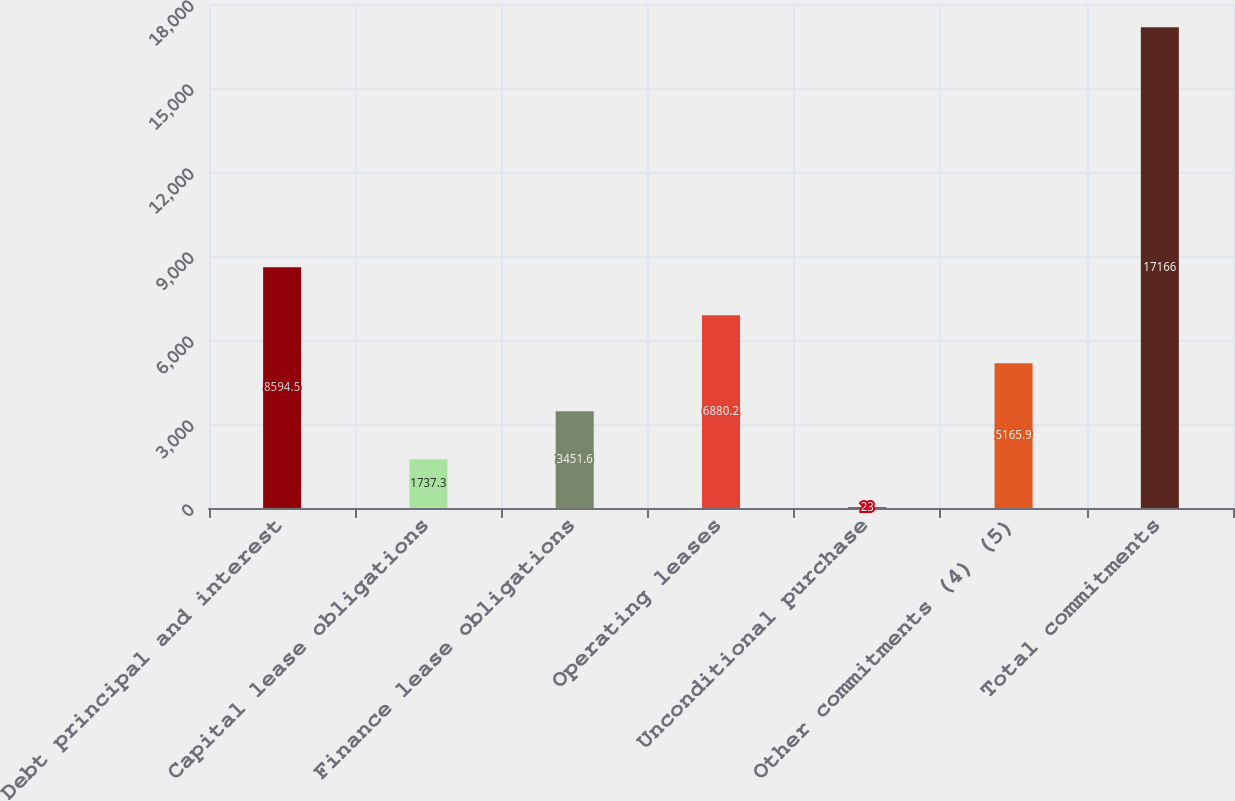Convert chart to OTSL. <chart><loc_0><loc_0><loc_500><loc_500><bar_chart><fcel>Debt principal and interest<fcel>Capital lease obligations<fcel>Finance lease obligations<fcel>Operating leases<fcel>Unconditional purchase<fcel>Other commitments (4) (5)<fcel>Total commitments<nl><fcel>8594.5<fcel>1737.3<fcel>3451.6<fcel>6880.2<fcel>23<fcel>5165.9<fcel>17166<nl></chart> 